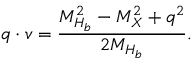<formula> <loc_0><loc_0><loc_500><loc_500>q \cdot v = { \frac { M _ { H _ { b } } ^ { 2 } - M _ { X } ^ { 2 } + q ^ { 2 } } { 2 M _ { H _ { b } } } } .</formula> 